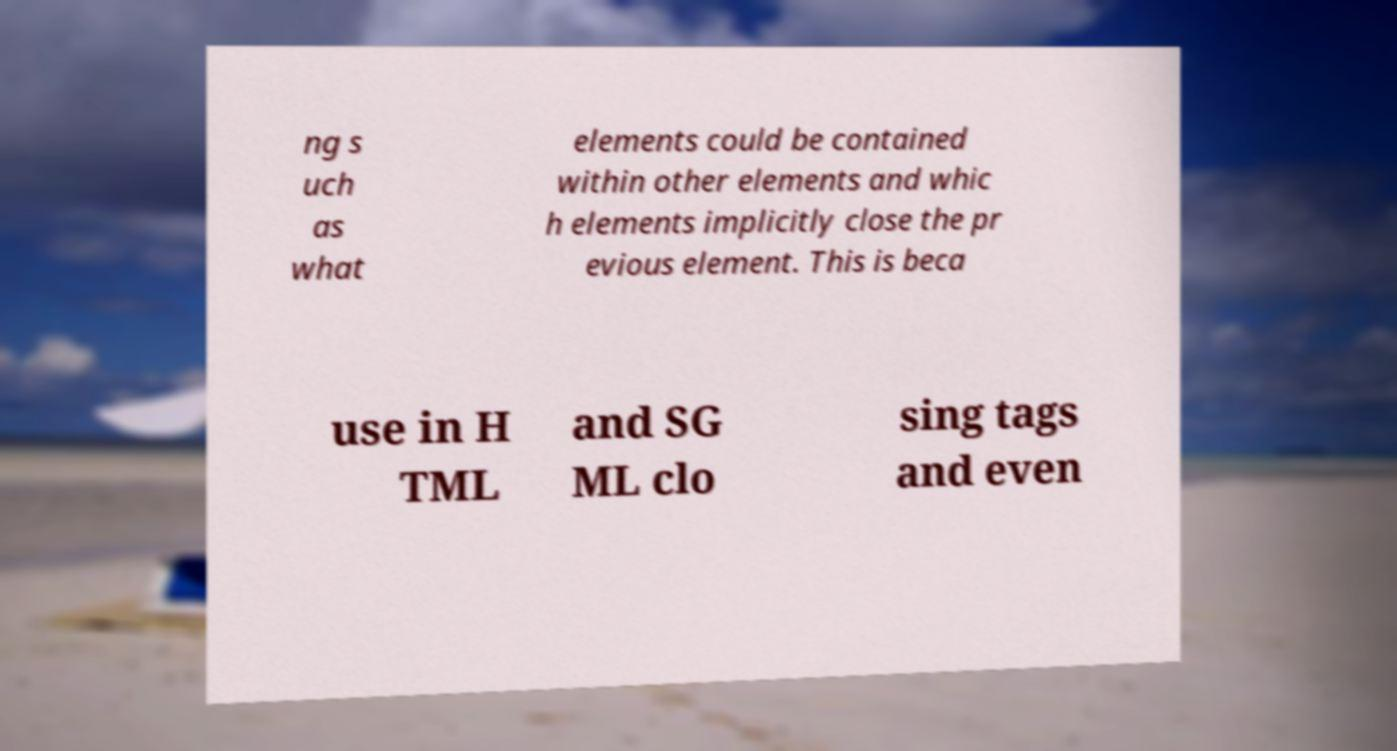Can you accurately transcribe the text from the provided image for me? ng s uch as what elements could be contained within other elements and whic h elements implicitly close the pr evious element. This is beca use in H TML and SG ML clo sing tags and even 